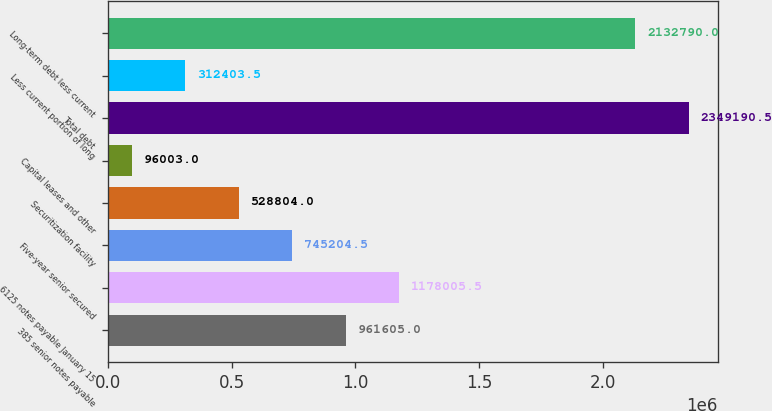<chart> <loc_0><loc_0><loc_500><loc_500><bar_chart><fcel>385 senior notes payable<fcel>6125 notes payable January 15<fcel>Five-year senior secured<fcel>Securitization facility<fcel>Capital leases and other<fcel>Total debt<fcel>Less current portion of long<fcel>Long-term debt less current<nl><fcel>961605<fcel>1.17801e+06<fcel>745204<fcel>528804<fcel>96003<fcel>2.34919e+06<fcel>312404<fcel>2.13279e+06<nl></chart> 